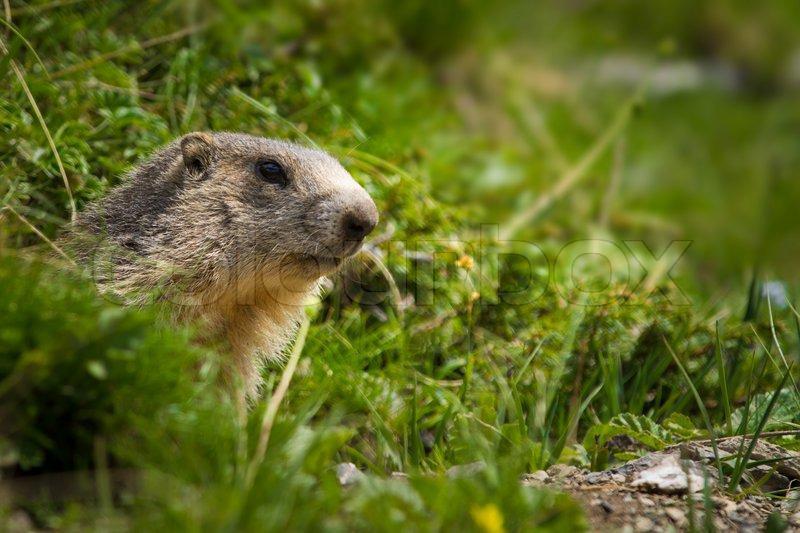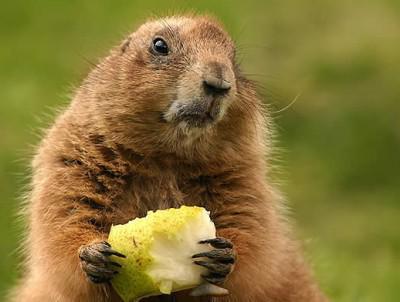The first image is the image on the left, the second image is the image on the right. Analyze the images presented: Is the assertion "Two groundhogs are standing very close together." valid? Answer yes or no. No. The first image is the image on the left, the second image is the image on the right. For the images shown, is this caption "There are two brown furry little animals outside." true? Answer yes or no. Yes. 